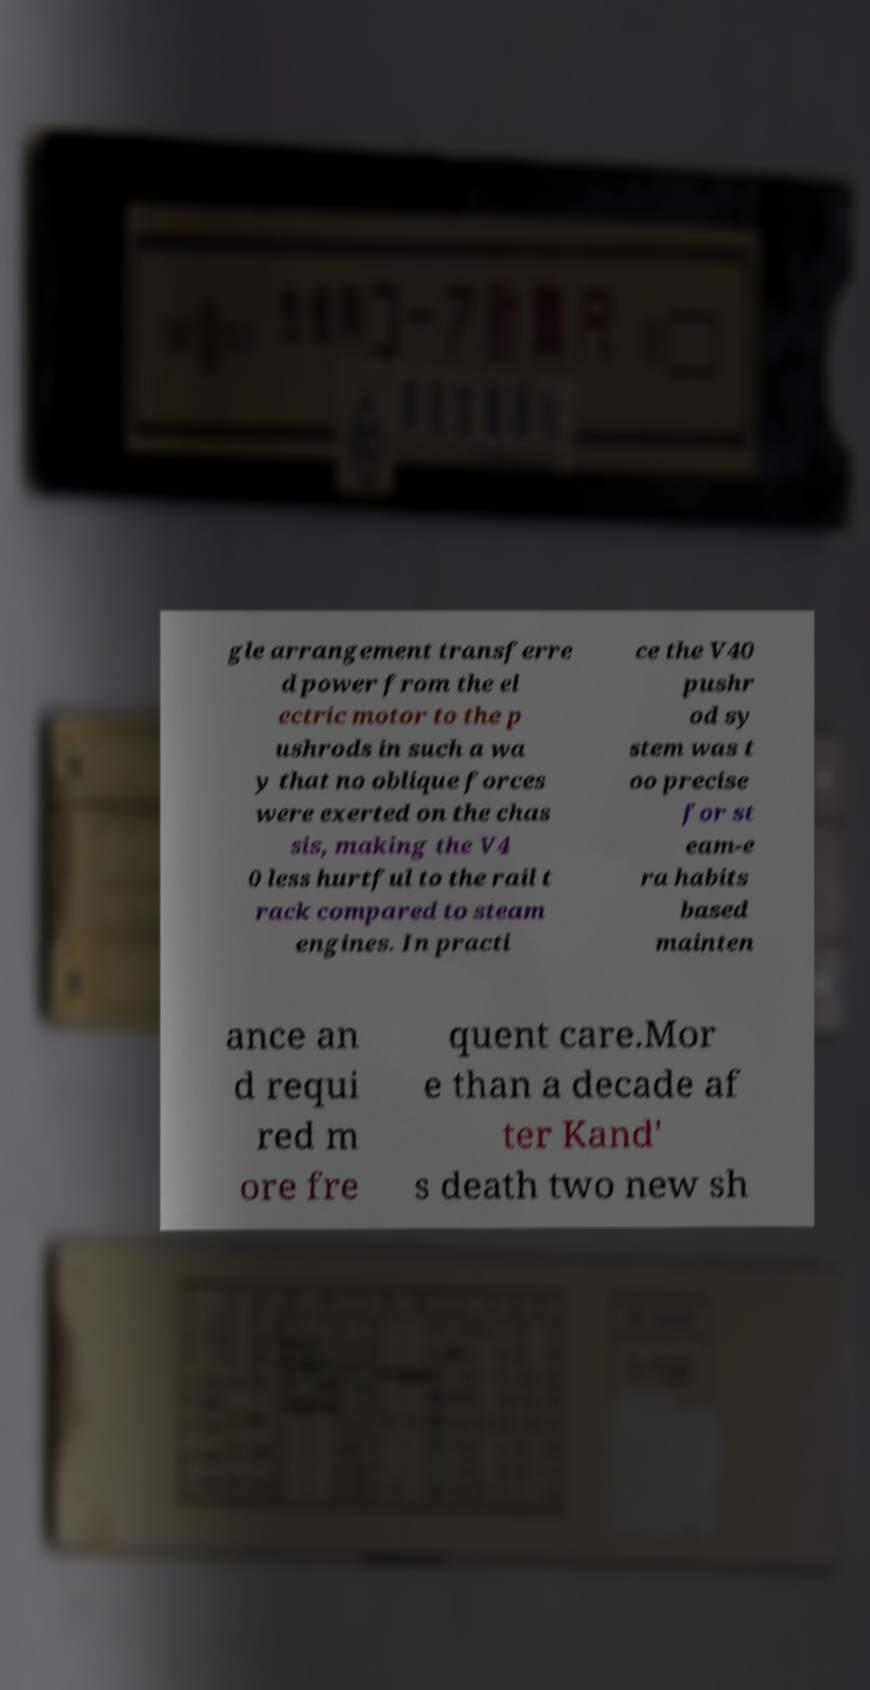What messages or text are displayed in this image? I need them in a readable, typed format. gle arrangement transferre d power from the el ectric motor to the p ushrods in such a wa y that no oblique forces were exerted on the chas sis, making the V4 0 less hurtful to the rail t rack compared to steam engines. In practi ce the V40 pushr od sy stem was t oo precise for st eam-e ra habits based mainten ance an d requi red m ore fre quent care.Mor e than a decade af ter Kand' s death two new sh 